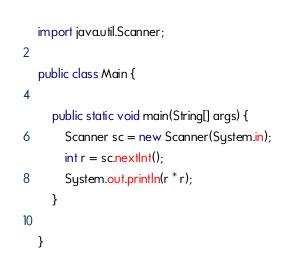<code> <loc_0><loc_0><loc_500><loc_500><_Java_>import java.util.Scanner;

public class Main {

	public static void main(String[] args) {
		Scanner sc = new Scanner(System.in);
		int r = sc.nextInt();
		System.out.println(r * r);
	}

}
</code> 